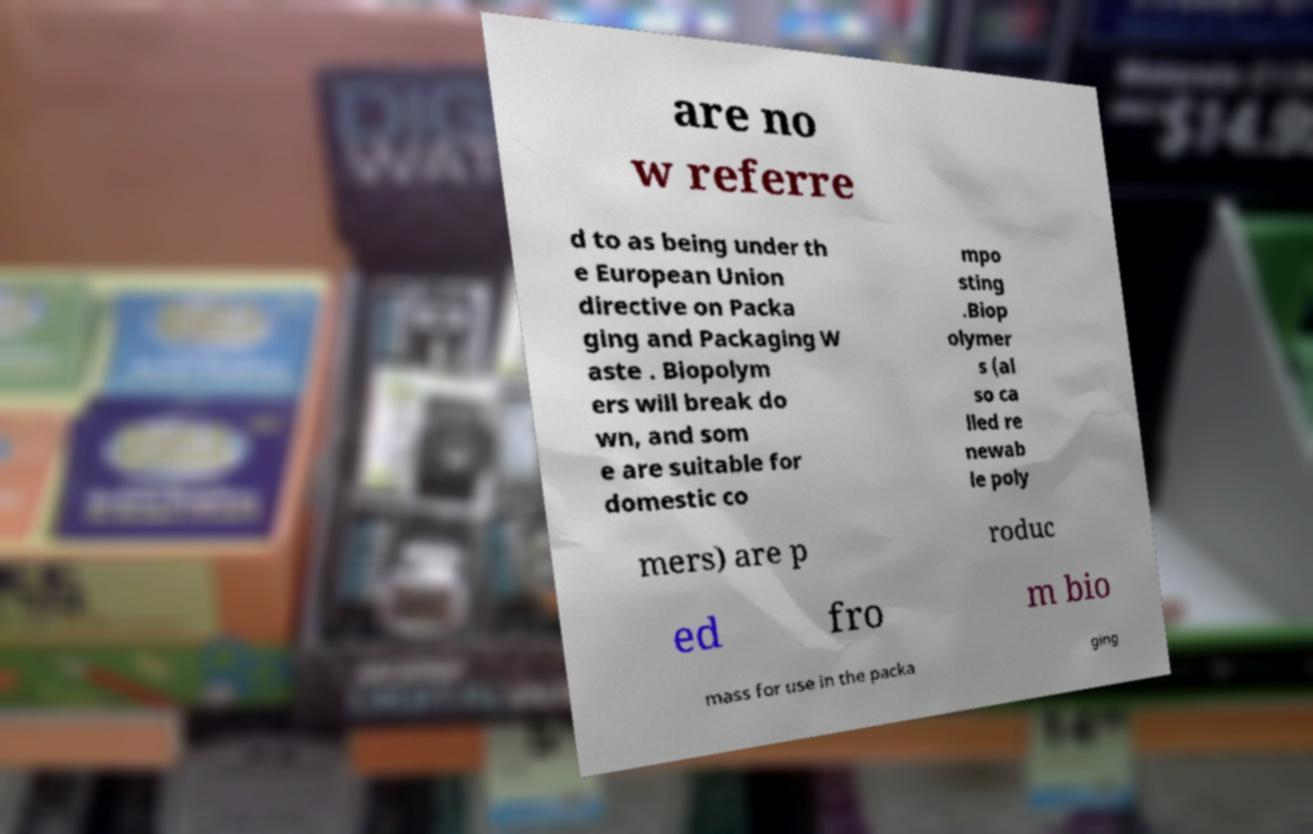Could you assist in decoding the text presented in this image and type it out clearly? are no w referre d to as being under th e European Union directive on Packa ging and Packaging W aste . Biopolym ers will break do wn, and som e are suitable for domestic co mpo sting .Biop olymer s (al so ca lled re newab le poly mers) are p roduc ed fro m bio mass for use in the packa ging 